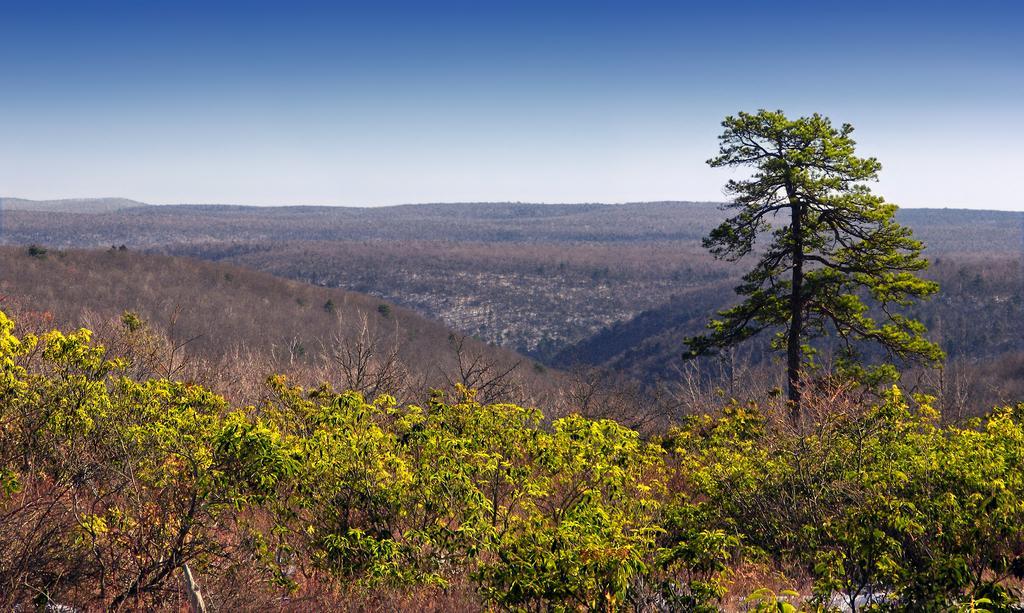Please provide a concise description of this image. In this image we can see there are some trees, mountains and sky. 